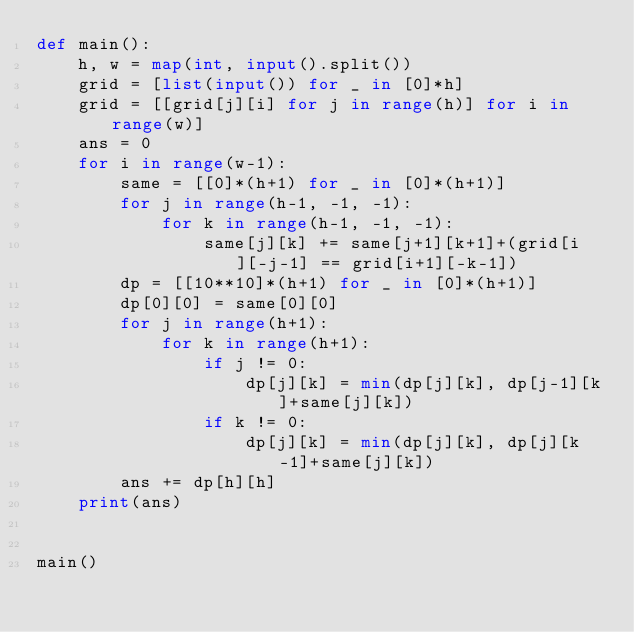<code> <loc_0><loc_0><loc_500><loc_500><_Python_>def main():
    h, w = map(int, input().split())
    grid = [list(input()) for _ in [0]*h]
    grid = [[grid[j][i] for j in range(h)] for i in range(w)]
    ans = 0
    for i in range(w-1):
        same = [[0]*(h+1) for _ in [0]*(h+1)]
        for j in range(h-1, -1, -1):
            for k in range(h-1, -1, -1):
                same[j][k] += same[j+1][k+1]+(grid[i][-j-1] == grid[i+1][-k-1])
        dp = [[10**10]*(h+1) for _ in [0]*(h+1)]
        dp[0][0] = same[0][0]
        for j in range(h+1):
            for k in range(h+1):
                if j != 0:
                    dp[j][k] = min(dp[j][k], dp[j-1][k]+same[j][k])
                if k != 0:
                    dp[j][k] = min(dp[j][k], dp[j][k-1]+same[j][k])
        ans += dp[h][h]
    print(ans)


main()
</code> 